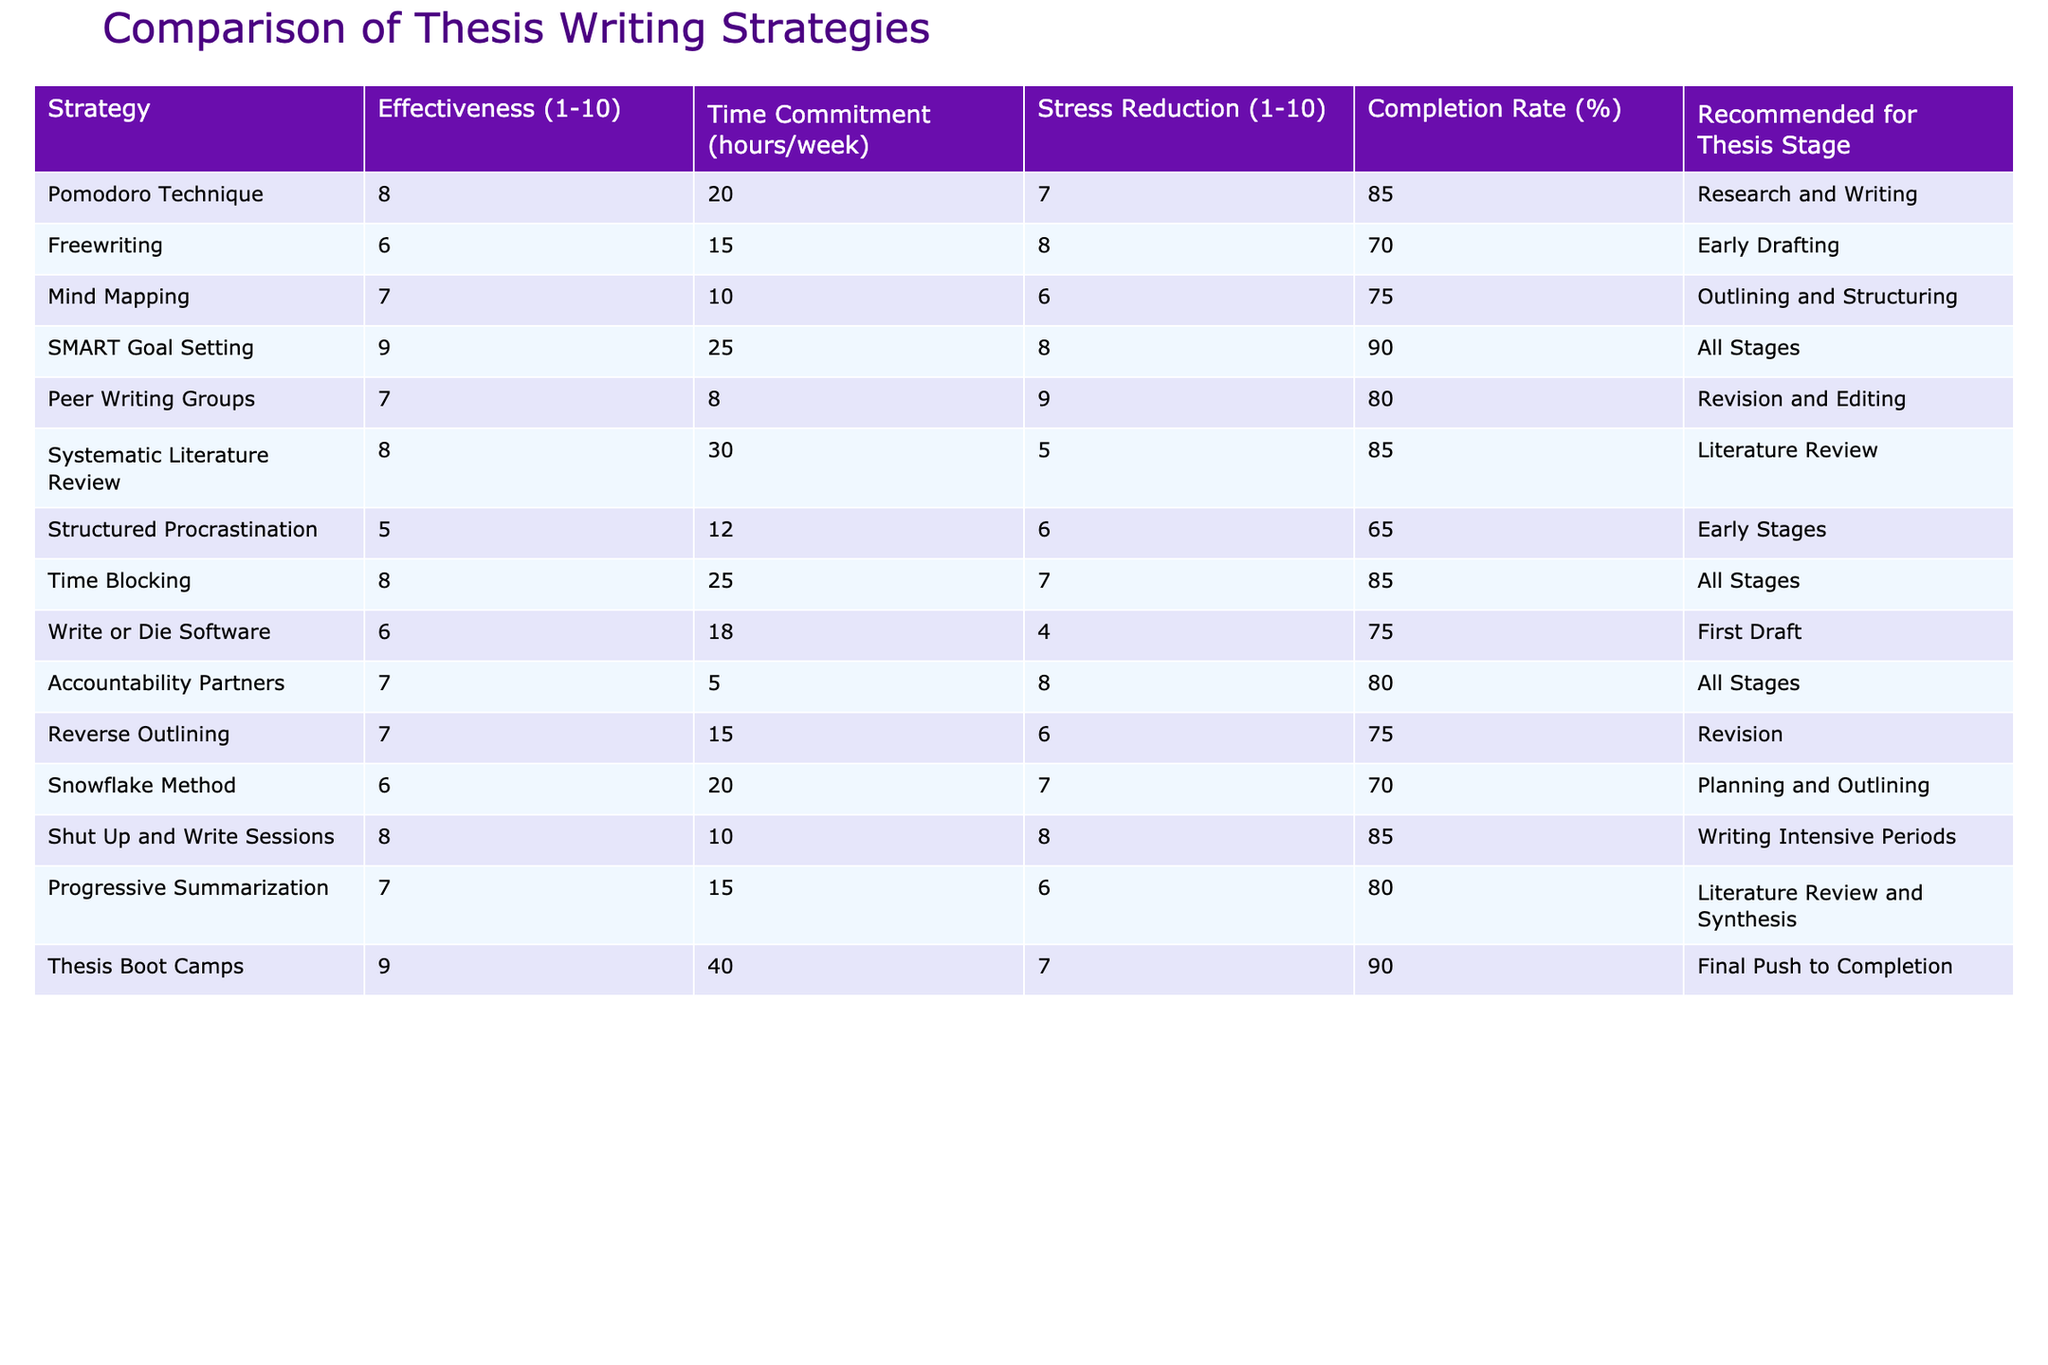What is the effectiveness score of the SMART Goal Setting strategy? The table lists the effectiveness score of each writing strategy. According to the table, the effectiveness score for SMART Goal Setting is 9.
Answer: 9 Which strategy has the highest completion rate? By examining the completion rates listed in the table, Thesis Boot Camps has the highest completion rate of 90%.
Answer: Thesis Boot Camps Is the Pomodoro Technique recommended for early drafting? The Pomodoro Technique is recommended for the Research and Writing stage, not specifically for early drafting. Thus, the answer is no.
Answer: No What is the average time commitment per week of the strategies recommended for 'All Stages'? The strategies recommended for 'All Stages' are SMART Goal Setting, Time Blocking, and Accountability Partners. Their respective time commitments are 25, 25, and 5 hours. The average time commitment is (25 + 25 + 5) / 3 = 55 / 3 ≈ 18.33 hours.
Answer: 18.33 hours Which strategy offers the best stress reduction score among those recommended for Literature Review? The recommendations for the Literature Review are Systematic Literature Review and Progressive Summarization, with stress reduction scores of 5 and 6, respectively. Progressive Summarization has the higher score.
Answer: Progressive Summarization What is the difference in effectiveness between the Structured Procrastination and Snowflake Method? The effectiveness score for Structured Procrastination is 5 and for the Snowflake Method is 6. The difference is 6 - 5 = 1.
Answer: 1 Are Peer Writing Groups more effective than Freewriting based on their effectiveness scores? Peer Writing Groups have an effectiveness score of 7, while Freewriting has a score of 6. Since 7 is greater than 6, the statement is true.
Answer: Yes How many strategies have a stress reduction score of 8 or higher? The strategies with a stress reduction score of 8 or higher are SMART Goal Setting, Peer Writing Groups, Accountability Partners, Shut Up and Write Sessions, and Thesis Boot Camps. This gives a total of 5 strategies.
Answer: 5 Which strategy requires the most hours per week? By checking the time commitment in the table, Thesis Boot Camps needs 40 hours a week, which is the highest among all strategies.
Answer: Thesis Boot Camps 